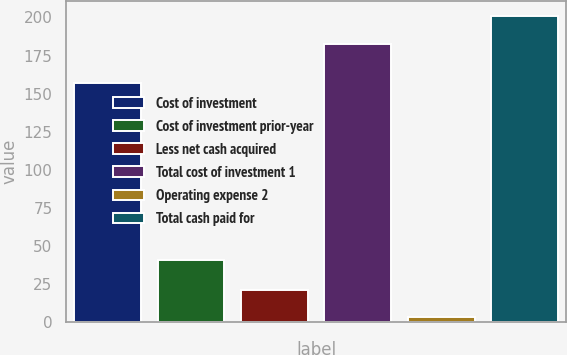Convert chart. <chart><loc_0><loc_0><loc_500><loc_500><bar_chart><fcel>Cost of investment<fcel>Cost of investment prior-year<fcel>Less net cash acquired<fcel>Total cost of investment 1<fcel>Operating expense 2<fcel>Total cash paid for<nl><fcel>156.8<fcel>40.6<fcel>21.46<fcel>182.6<fcel>3.2<fcel>200.86<nl></chart> 